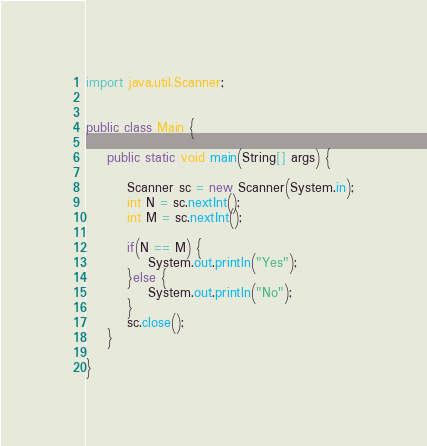<code> <loc_0><loc_0><loc_500><loc_500><_Java_>import java.util.Scanner;

 
public class Main {
 
	public static void main(String[] args) {
		
		Scanner sc = new Scanner(System.in);
		int N = sc.nextInt();
		int M = sc.nextInt();
		
		if(N == M) {
			System.out.println("Yes");
		}else {
			System.out.println("No");
		}
		sc.close();
	}
	
}</code> 